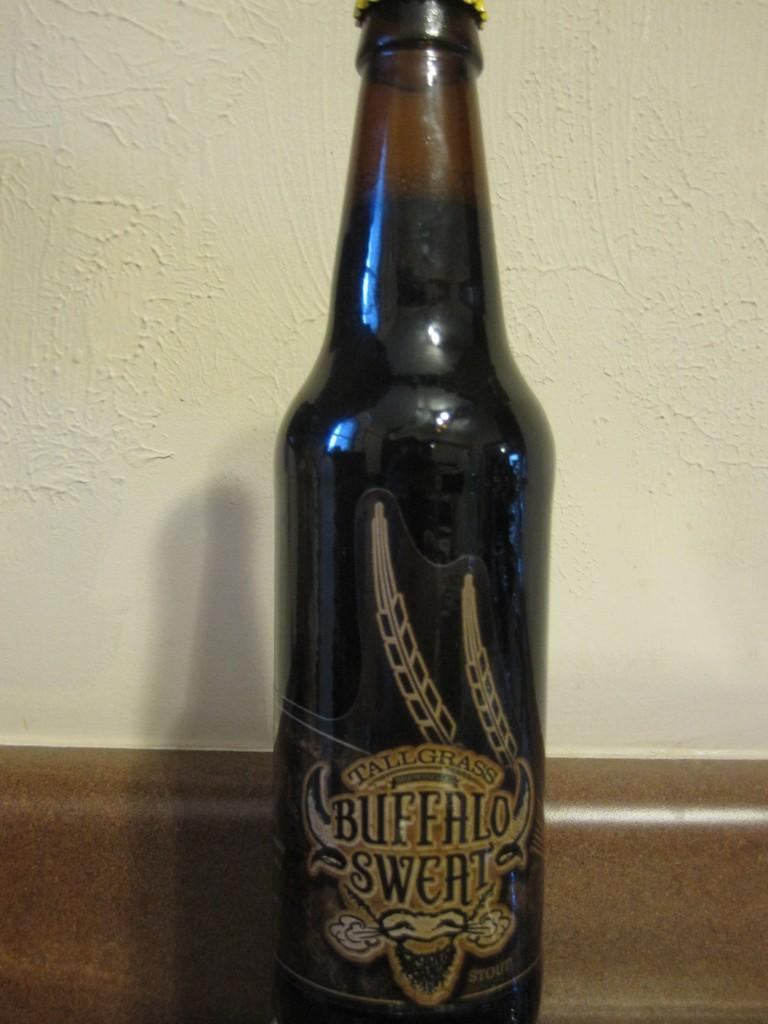<image>
Create a compact narrative representing the image presented. A bottle of Tallgrass Buffalo Sweat beer on a counter. 